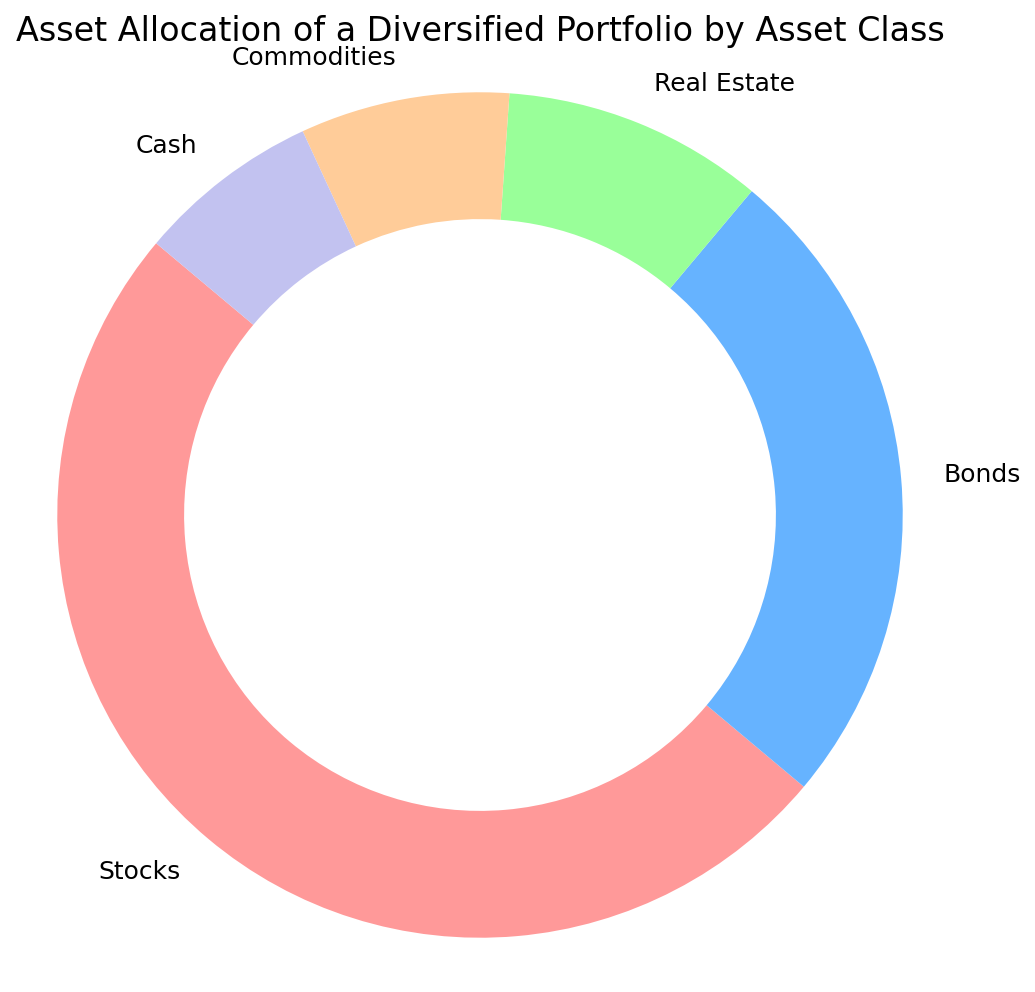What percentage of the portfolio is allocated to Stocks and Bonds combined? Add the percentages for Stocks and Bonds: 50% + 25% = 75%.
Answer: 75% Which asset class has the smallest percentage allocation? The asset with the smallest slice or lightest color in the ring chart is Cash at 7%.
Answer: Cash How much larger is the Stocks allocation than the Real Estate allocation? Subtract the Real Estate percentage from the Stocks percentage: 50% - 10% = 40%.
Answer: 40% What percentage of the portfolio is allocated to Real Estate and Commodities combined? Add the percentages for Real Estate and Commodities: 10% + 8% = 18%.
Answer: 18% Does the allocation to Bonds exceed the combined allocation to Commodities and Cash? Calculate the combined allocation for Commodities and Cash: 8% + 7% = 15%. Compare it with Bonds: 25% > 15%.
Answer: Yes What color represents Commodities in the chart? Identify the color corresponding to the segment labeled Commodities, which is light orange.
Answer: Light Orange Between Bonds and Real Estate, which asset class has a larger allocation and by how much? Bonds have 25% and Real Estate has 10%. The difference is 25% - 10% = 15%.
Answer: Bonds by 15% How many asset classes have an allocation greater than 10%? Identify the asset classes: Stocks (50%), Bonds (25%). Only these two are greater than 10%.
Answer: 2 What is the average allocation percentage across all asset classes? Sum all percentages and divide by the number of asset classes: (50% + 25% + 10% + 8% + 7%) / 5 = 20%.
Answer: 20% Which asset classes, combined, equal or exceed the allocation to Stocks? Add combinations to see which meet or exceed 50%. Bonds (25%) + Real Estate (10%) + Commodities (8%) + Cash (7%): 25% + 10% + 8% + 7% = 50%. These four combined equal the allocation to Stocks.
Answer: Bonds, Real Estate, Commodities, Cash 